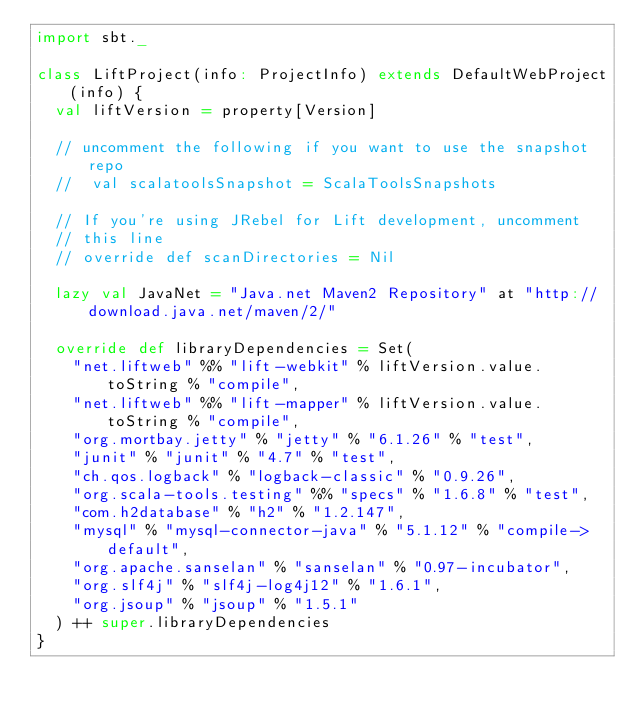Convert code to text. <code><loc_0><loc_0><loc_500><loc_500><_Scala_>import sbt._

class LiftProject(info: ProjectInfo) extends DefaultWebProject(info) {
  val liftVersion = property[Version]

  // uncomment the following if you want to use the snapshot repo
  //  val scalatoolsSnapshot = ScalaToolsSnapshots

  // If you're using JRebel for Lift development, uncomment
  // this line
  // override def scanDirectories = Nil

  lazy val JavaNet = "Java.net Maven2 Repository" at "http://download.java.net/maven/2/"

  override def libraryDependencies = Set(
    "net.liftweb" %% "lift-webkit" % liftVersion.value.toString % "compile",
    "net.liftweb" %% "lift-mapper" % liftVersion.value.toString % "compile",
    "org.mortbay.jetty" % "jetty" % "6.1.26" % "test",
    "junit" % "junit" % "4.7" % "test",
    "ch.qos.logback" % "logback-classic" % "0.9.26",
    "org.scala-tools.testing" %% "specs" % "1.6.8" % "test",
    "com.h2database" % "h2" % "1.2.147",
    "mysql" % "mysql-connector-java" % "5.1.12" % "compile->default",
    "org.apache.sanselan" % "sanselan" % "0.97-incubator",
    "org.slf4j" % "slf4j-log4j12" % "1.6.1",
    "org.jsoup" % "jsoup" % "1.5.1"
  ) ++ super.libraryDependencies
}
</code> 